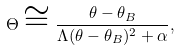Convert formula to latex. <formula><loc_0><loc_0><loc_500><loc_500>\Theta \cong \frac { \theta - \theta _ { B } } { \Lambda ( \theta - \theta _ { B } ) ^ { 2 } + \alpha } ,</formula> 